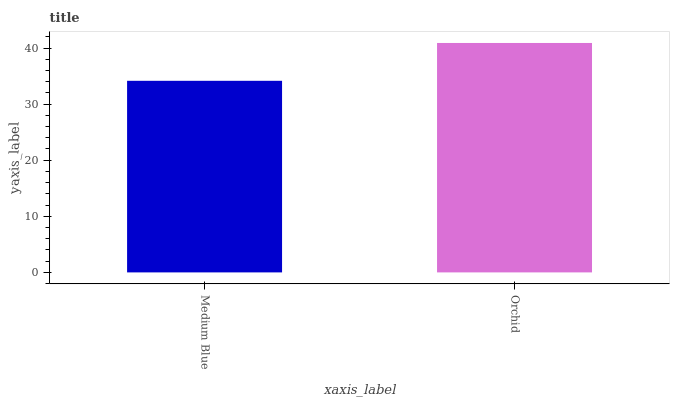Is Medium Blue the minimum?
Answer yes or no. Yes. Is Orchid the maximum?
Answer yes or no. Yes. Is Orchid the minimum?
Answer yes or no. No. Is Orchid greater than Medium Blue?
Answer yes or no. Yes. Is Medium Blue less than Orchid?
Answer yes or no. Yes. Is Medium Blue greater than Orchid?
Answer yes or no. No. Is Orchid less than Medium Blue?
Answer yes or no. No. Is Orchid the high median?
Answer yes or no. Yes. Is Medium Blue the low median?
Answer yes or no. Yes. Is Medium Blue the high median?
Answer yes or no. No. Is Orchid the low median?
Answer yes or no. No. 